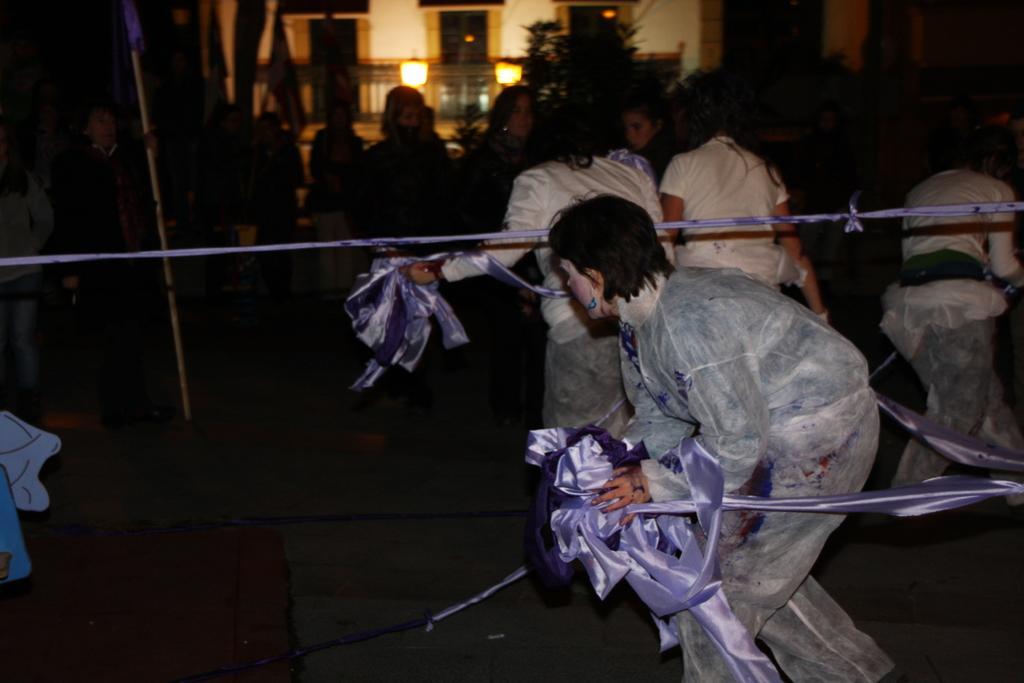Could you give a brief overview of what you see in this image? On the right side a woman is walking by holding the ribbon, she wore coat. In the middle few persons are walking there are lights to the building in this image. 